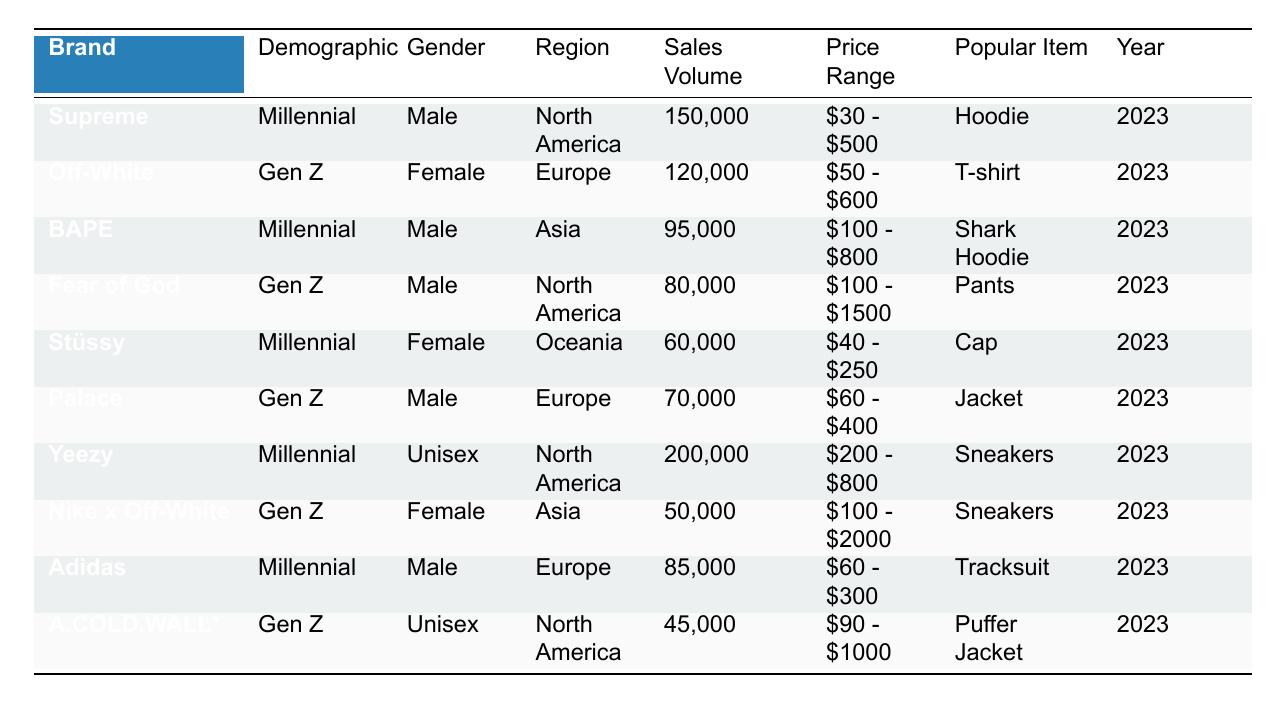What streetwear brand had the highest sales volume in 2023? The brand with the highest sales volume is Yeezy, with a sales volume of 200,000.
Answer: Yeezy Which demographic had the lowest sales volume contribution? The demographic with the lowest sales volume is Gen Z, Unisex, represented by A.COLD.WALL* with 45,000 in sales.
Answer: Gen Z, Unisex How many brands targeted Millennials and what was their total sales volume? Three brands targeted Millennials: Supreme, BAPE, and Yeezy. Their total sales volume is 150,000 + 95,000 + 200,000 = 445,000.
Answer: 445,000 Is there any brand for Gen Z targeting female customers that have sales over 100,000? Yes, the brand Off-White targeted Gen Z female customers and had sales of 120,000, which is over 100,000.
Answer: Yes What is the price range of the most popular item sold by Adidas? The most popular item sold by Adidas is a Tracksuit, and the price range for it is $60 - $300.
Answer: $60 - $300 Among the Gen Z brands, which one had the lowest sales volume and what was it? The Gen Z brand with the lowest sales volume is A.COLD.WALL*, with a sales volume of 45,000.
Answer: A.COLD.WALL*, 45,000 What are the popular items for Millennial male customers, and how does their sales volume compare to Millennial female customers? The popular items for Millennial male customers are Hoodies by Supreme (150,000) and Shark Hoodies by BAPE (95,000). For Millennial females, it is Caps by Stüssy (60,000). Their total sales volume is 150,000 + 95,000 = 245,000 for males and 60,000 for females, making male sales higher.
Answer: Males: 245,000, Females: 60,000 What is the total sales volume from brands located in North America? The brands located in North America are Supreme (150,000), Yeezy (200,000), and Fear of God (80,000). Summing their sales gives 150,000 + 200,000 + 80,000 = 430,000.
Answer: 430,000 Which brand in Asia has the highest sales volume and what item did they sell? BAPE is the only brand in Asia with a sales volume of 95,000, selling Shark Hoodies, which is the highest for an Asia brand.
Answer: BAPE, Shark Hoodie How does the average sales volume of Gen Z brands compare to that of Millennial brands? There are four Gen Z brands with sales volumes: Off-White (120,000), Fear of God (80,000), Palace (70,000), and A.COLD.WALL* (45,000) with a total of 315,000; average is 315,000 / 4 = 78,750. For Millennials, there are four brands as well with a total of 445,000; average is 445,000 / 4 = 111,250. Comparing, Millennial average (111,250) is higher than Gen Z average (78,750).
Answer: Millennial average is higher 